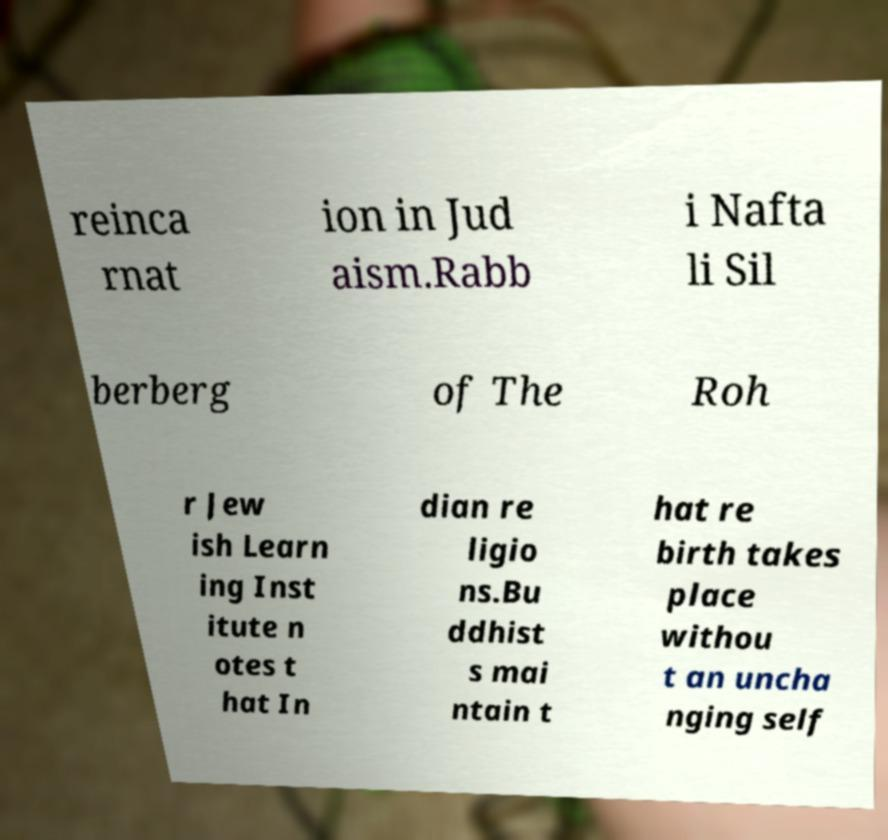Can you read and provide the text displayed in the image?This photo seems to have some interesting text. Can you extract and type it out for me? reinca rnat ion in Jud aism.Rabb i Nafta li Sil berberg of The Roh r Jew ish Learn ing Inst itute n otes t hat In dian re ligio ns.Bu ddhist s mai ntain t hat re birth takes place withou t an uncha nging self 